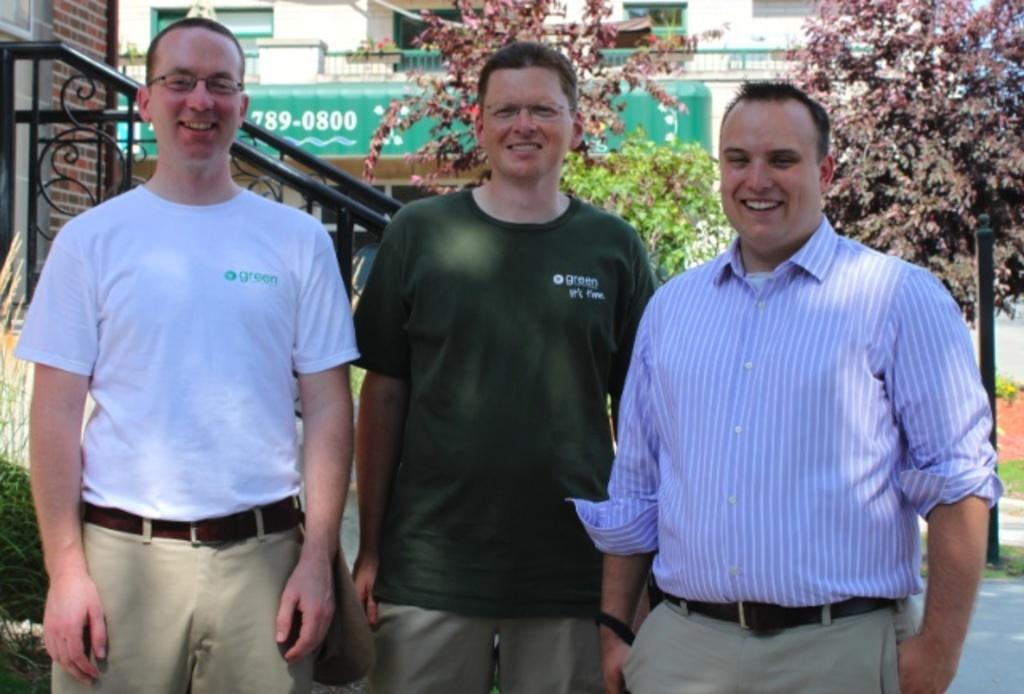Can you describe this image briefly? In this picture we can see three men are standing and smiling, in the background there is a building, we can see trees in the middle, on the left side there is a wall. 